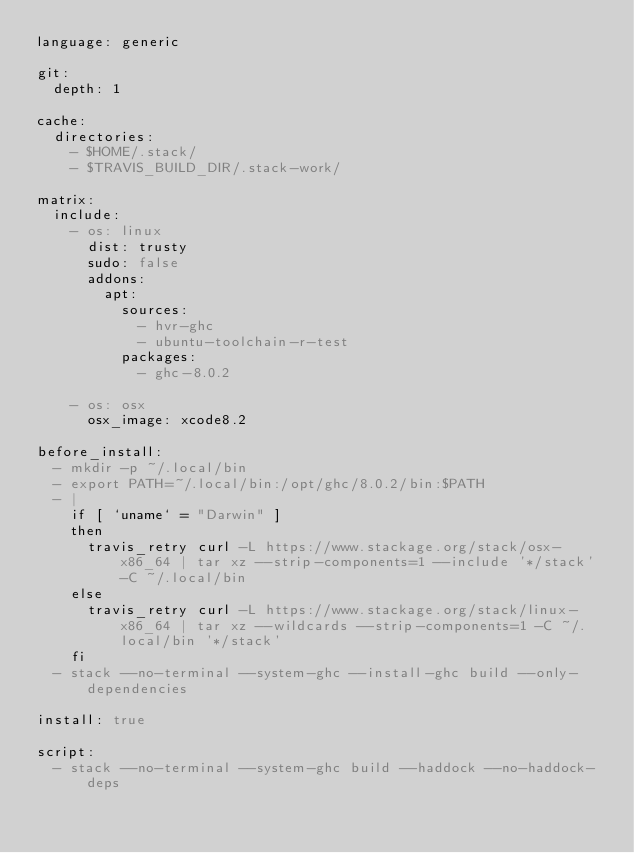Convert code to text. <code><loc_0><loc_0><loc_500><loc_500><_YAML_>language: generic

git:
  depth: 1

cache:
  directories:
    - $HOME/.stack/
    - $TRAVIS_BUILD_DIR/.stack-work/

matrix:
  include:
    - os: linux
      dist: trusty
      sudo: false
      addons:
        apt:
          sources:
            - hvr-ghc
            - ubuntu-toolchain-r-test
          packages:
            - ghc-8.0.2

    - os: osx
      osx_image: xcode8.2

before_install:
  - mkdir -p ~/.local/bin
  - export PATH=~/.local/bin:/opt/ghc/8.0.2/bin:$PATH
  - |
    if [ `uname` = "Darwin" ]
    then
      travis_retry curl -L https://www.stackage.org/stack/osx-x86_64 | tar xz --strip-components=1 --include '*/stack' -C ~/.local/bin
    else
      travis_retry curl -L https://www.stackage.org/stack/linux-x86_64 | tar xz --wildcards --strip-components=1 -C ~/.local/bin '*/stack'
    fi
  - stack --no-terminal --system-ghc --install-ghc build --only-dependencies

install: true

script:
  - stack --no-terminal --system-ghc build --haddock --no-haddock-deps
</code> 